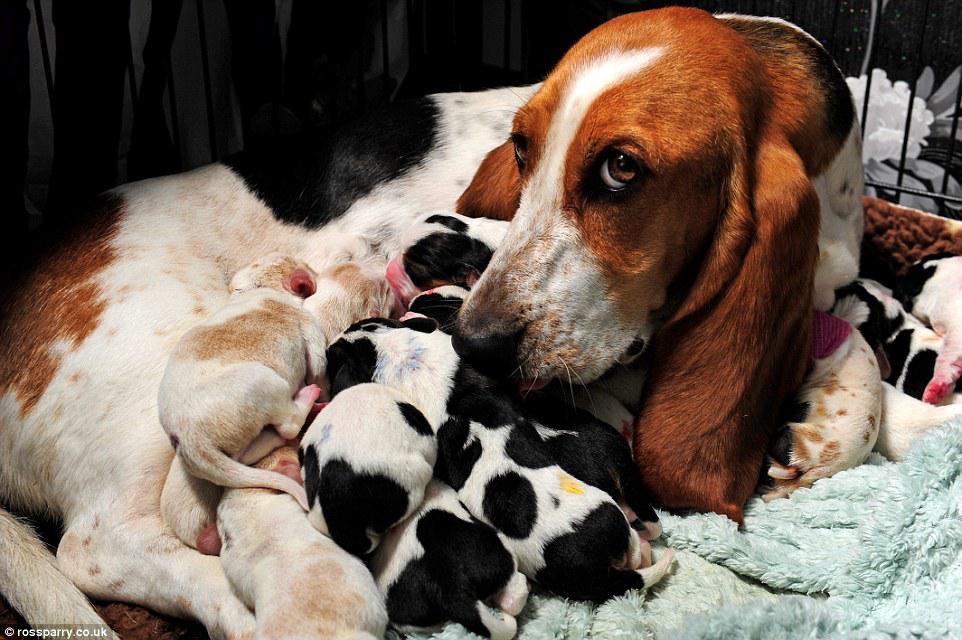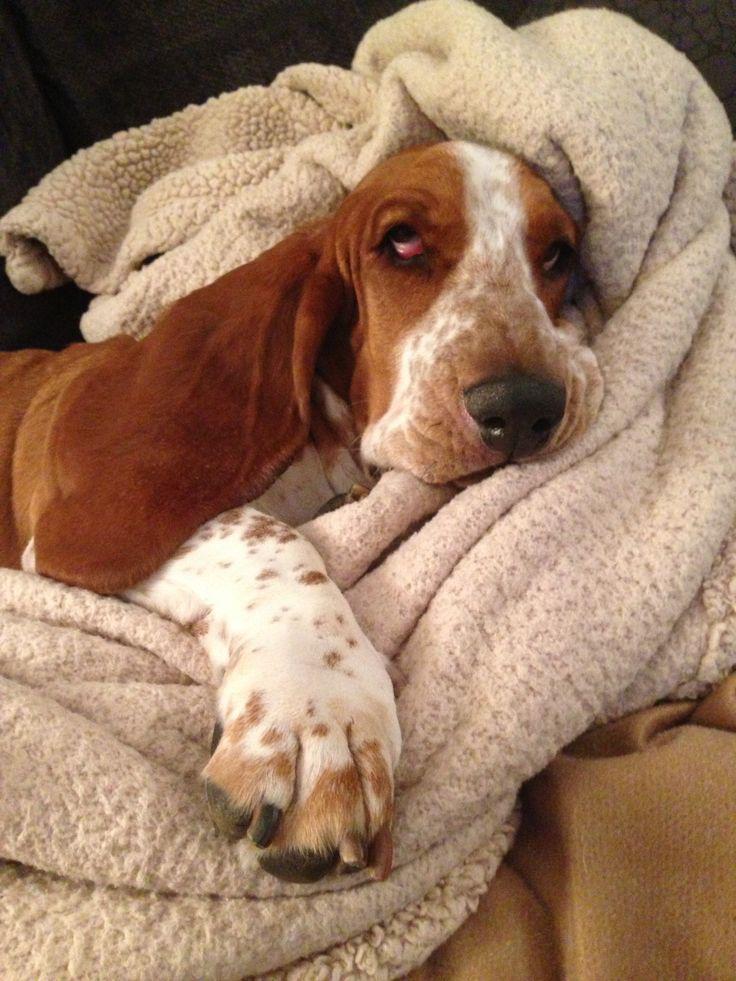The first image is the image on the left, the second image is the image on the right. Evaluate the accuracy of this statement regarding the images: "Each image contains one basset hound, and one hound lies on his back while the other hound lies on his stomach with his head flat.". Is it true? Answer yes or no. No. 